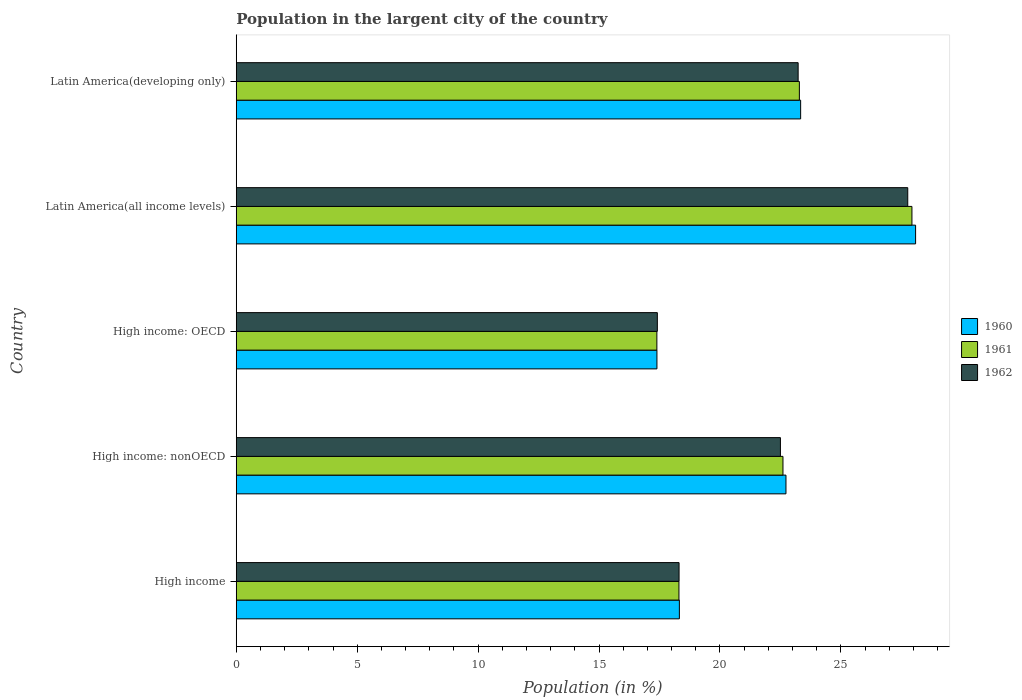Are the number of bars per tick equal to the number of legend labels?
Offer a terse response. Yes. What is the label of the 1st group of bars from the top?
Your answer should be compact. Latin America(developing only). What is the percentage of population in the largent city in 1962 in Latin America(developing only)?
Provide a short and direct response. 23.23. Across all countries, what is the maximum percentage of population in the largent city in 1960?
Give a very brief answer. 28.09. Across all countries, what is the minimum percentage of population in the largent city in 1961?
Your answer should be compact. 17.39. In which country was the percentage of population in the largent city in 1961 maximum?
Keep it short and to the point. Latin America(all income levels). In which country was the percentage of population in the largent city in 1962 minimum?
Your response must be concise. High income: OECD. What is the total percentage of population in the largent city in 1960 in the graph?
Offer a terse response. 109.87. What is the difference between the percentage of population in the largent city in 1962 in High income and that in High income: OECD?
Provide a short and direct response. 0.9. What is the difference between the percentage of population in the largent city in 1962 in High income: OECD and the percentage of population in the largent city in 1960 in Latin America(developing only)?
Your answer should be very brief. -5.93. What is the average percentage of population in the largent city in 1961 per country?
Your answer should be compact. 21.9. What is the difference between the percentage of population in the largent city in 1960 and percentage of population in the largent city in 1961 in Latin America(all income levels)?
Keep it short and to the point. 0.15. In how many countries, is the percentage of population in the largent city in 1961 greater than 10 %?
Your response must be concise. 5. What is the ratio of the percentage of population in the largent city in 1960 in High income to that in Latin America(all income levels)?
Offer a terse response. 0.65. What is the difference between the highest and the second highest percentage of population in the largent city in 1960?
Offer a terse response. 4.75. What is the difference between the highest and the lowest percentage of population in the largent city in 1962?
Make the answer very short. 10.35. Is the sum of the percentage of population in the largent city in 1960 in High income and High income: nonOECD greater than the maximum percentage of population in the largent city in 1961 across all countries?
Offer a very short reply. Yes. What does the 1st bar from the bottom in High income represents?
Offer a very short reply. 1960. How many countries are there in the graph?
Provide a short and direct response. 5. Are the values on the major ticks of X-axis written in scientific E-notation?
Your response must be concise. No. How are the legend labels stacked?
Offer a terse response. Vertical. What is the title of the graph?
Offer a terse response. Population in the largent city of the country. Does "1977" appear as one of the legend labels in the graph?
Ensure brevity in your answer.  No. What is the Population (in %) of 1960 in High income?
Offer a terse response. 18.32. What is the Population (in %) of 1961 in High income?
Your answer should be compact. 18.3. What is the Population (in %) in 1962 in High income?
Offer a terse response. 18.31. What is the Population (in %) in 1960 in High income: nonOECD?
Your answer should be very brief. 22.73. What is the Population (in %) of 1961 in High income: nonOECD?
Ensure brevity in your answer.  22.61. What is the Population (in %) in 1962 in High income: nonOECD?
Your response must be concise. 22.5. What is the Population (in %) of 1960 in High income: OECD?
Offer a very short reply. 17.39. What is the Population (in %) of 1961 in High income: OECD?
Keep it short and to the point. 17.39. What is the Population (in %) of 1962 in High income: OECD?
Make the answer very short. 17.41. What is the Population (in %) of 1960 in Latin America(all income levels)?
Offer a very short reply. 28.09. What is the Population (in %) of 1961 in Latin America(all income levels)?
Your answer should be compact. 27.94. What is the Population (in %) in 1962 in Latin America(all income levels)?
Your answer should be very brief. 27.76. What is the Population (in %) of 1960 in Latin America(developing only)?
Give a very brief answer. 23.34. What is the Population (in %) of 1961 in Latin America(developing only)?
Your answer should be compact. 23.28. What is the Population (in %) in 1962 in Latin America(developing only)?
Make the answer very short. 23.23. Across all countries, what is the maximum Population (in %) of 1960?
Your answer should be very brief. 28.09. Across all countries, what is the maximum Population (in %) of 1961?
Your answer should be very brief. 27.94. Across all countries, what is the maximum Population (in %) in 1962?
Ensure brevity in your answer.  27.76. Across all countries, what is the minimum Population (in %) of 1960?
Provide a succinct answer. 17.39. Across all countries, what is the minimum Population (in %) in 1961?
Give a very brief answer. 17.39. Across all countries, what is the minimum Population (in %) of 1962?
Provide a short and direct response. 17.41. What is the total Population (in %) of 1960 in the graph?
Keep it short and to the point. 109.87. What is the total Population (in %) of 1961 in the graph?
Give a very brief answer. 109.52. What is the total Population (in %) of 1962 in the graph?
Ensure brevity in your answer.  109.22. What is the difference between the Population (in %) of 1960 in High income and that in High income: nonOECD?
Your answer should be very brief. -4.41. What is the difference between the Population (in %) of 1961 in High income and that in High income: nonOECD?
Provide a succinct answer. -4.3. What is the difference between the Population (in %) in 1962 in High income and that in High income: nonOECD?
Provide a short and direct response. -4.19. What is the difference between the Population (in %) in 1960 in High income and that in High income: OECD?
Your response must be concise. 0.93. What is the difference between the Population (in %) of 1961 in High income and that in High income: OECD?
Give a very brief answer. 0.91. What is the difference between the Population (in %) of 1962 in High income and that in High income: OECD?
Provide a succinct answer. 0.9. What is the difference between the Population (in %) in 1960 in High income and that in Latin America(all income levels)?
Ensure brevity in your answer.  -9.77. What is the difference between the Population (in %) in 1961 in High income and that in Latin America(all income levels)?
Give a very brief answer. -9.63. What is the difference between the Population (in %) in 1962 in High income and that in Latin America(all income levels)?
Your answer should be compact. -9.46. What is the difference between the Population (in %) of 1960 in High income and that in Latin America(developing only)?
Provide a short and direct response. -5.01. What is the difference between the Population (in %) in 1961 in High income and that in Latin America(developing only)?
Ensure brevity in your answer.  -4.98. What is the difference between the Population (in %) in 1962 in High income and that in Latin America(developing only)?
Ensure brevity in your answer.  -4.92. What is the difference between the Population (in %) in 1960 in High income: nonOECD and that in High income: OECD?
Provide a short and direct response. 5.34. What is the difference between the Population (in %) of 1961 in High income: nonOECD and that in High income: OECD?
Your response must be concise. 5.21. What is the difference between the Population (in %) in 1962 in High income: nonOECD and that in High income: OECD?
Make the answer very short. 5.09. What is the difference between the Population (in %) in 1960 in High income: nonOECD and that in Latin America(all income levels)?
Make the answer very short. -5.36. What is the difference between the Population (in %) of 1961 in High income: nonOECD and that in Latin America(all income levels)?
Ensure brevity in your answer.  -5.33. What is the difference between the Population (in %) of 1962 in High income: nonOECD and that in Latin America(all income levels)?
Offer a very short reply. -5.26. What is the difference between the Population (in %) of 1960 in High income: nonOECD and that in Latin America(developing only)?
Offer a terse response. -0.61. What is the difference between the Population (in %) of 1961 in High income: nonOECD and that in Latin America(developing only)?
Provide a short and direct response. -0.68. What is the difference between the Population (in %) in 1962 in High income: nonOECD and that in Latin America(developing only)?
Provide a succinct answer. -0.73. What is the difference between the Population (in %) in 1960 in High income: OECD and that in Latin America(all income levels)?
Give a very brief answer. -10.69. What is the difference between the Population (in %) in 1961 in High income: OECD and that in Latin America(all income levels)?
Keep it short and to the point. -10.55. What is the difference between the Population (in %) in 1962 in High income: OECD and that in Latin America(all income levels)?
Your answer should be very brief. -10.35. What is the difference between the Population (in %) in 1960 in High income: OECD and that in Latin America(developing only)?
Offer a terse response. -5.94. What is the difference between the Population (in %) of 1961 in High income: OECD and that in Latin America(developing only)?
Make the answer very short. -5.89. What is the difference between the Population (in %) in 1962 in High income: OECD and that in Latin America(developing only)?
Offer a terse response. -5.82. What is the difference between the Population (in %) in 1960 in Latin America(all income levels) and that in Latin America(developing only)?
Your answer should be compact. 4.75. What is the difference between the Population (in %) of 1961 in Latin America(all income levels) and that in Latin America(developing only)?
Provide a short and direct response. 4.65. What is the difference between the Population (in %) in 1962 in Latin America(all income levels) and that in Latin America(developing only)?
Offer a very short reply. 4.53. What is the difference between the Population (in %) in 1960 in High income and the Population (in %) in 1961 in High income: nonOECD?
Offer a terse response. -4.28. What is the difference between the Population (in %) in 1960 in High income and the Population (in %) in 1962 in High income: nonOECD?
Keep it short and to the point. -4.18. What is the difference between the Population (in %) of 1961 in High income and the Population (in %) of 1962 in High income: nonOECD?
Your answer should be very brief. -4.2. What is the difference between the Population (in %) of 1960 in High income and the Population (in %) of 1961 in High income: OECD?
Your answer should be very brief. 0.93. What is the difference between the Population (in %) of 1960 in High income and the Population (in %) of 1962 in High income: OECD?
Provide a short and direct response. 0.91. What is the difference between the Population (in %) of 1961 in High income and the Population (in %) of 1962 in High income: OECD?
Ensure brevity in your answer.  0.89. What is the difference between the Population (in %) in 1960 in High income and the Population (in %) in 1961 in Latin America(all income levels)?
Offer a terse response. -9.62. What is the difference between the Population (in %) of 1960 in High income and the Population (in %) of 1962 in Latin America(all income levels)?
Your answer should be compact. -9.44. What is the difference between the Population (in %) of 1961 in High income and the Population (in %) of 1962 in Latin America(all income levels)?
Keep it short and to the point. -9.46. What is the difference between the Population (in %) of 1960 in High income and the Population (in %) of 1961 in Latin America(developing only)?
Your response must be concise. -4.96. What is the difference between the Population (in %) of 1960 in High income and the Population (in %) of 1962 in Latin America(developing only)?
Provide a short and direct response. -4.91. What is the difference between the Population (in %) of 1961 in High income and the Population (in %) of 1962 in Latin America(developing only)?
Offer a terse response. -4.93. What is the difference between the Population (in %) of 1960 in High income: nonOECD and the Population (in %) of 1961 in High income: OECD?
Keep it short and to the point. 5.34. What is the difference between the Population (in %) in 1960 in High income: nonOECD and the Population (in %) in 1962 in High income: OECD?
Offer a terse response. 5.32. What is the difference between the Population (in %) in 1961 in High income: nonOECD and the Population (in %) in 1962 in High income: OECD?
Offer a very short reply. 5.19. What is the difference between the Population (in %) of 1960 in High income: nonOECD and the Population (in %) of 1961 in Latin America(all income levels)?
Make the answer very short. -5.21. What is the difference between the Population (in %) of 1960 in High income: nonOECD and the Population (in %) of 1962 in Latin America(all income levels)?
Make the answer very short. -5.04. What is the difference between the Population (in %) in 1961 in High income: nonOECD and the Population (in %) in 1962 in Latin America(all income levels)?
Ensure brevity in your answer.  -5.16. What is the difference between the Population (in %) of 1960 in High income: nonOECD and the Population (in %) of 1961 in Latin America(developing only)?
Ensure brevity in your answer.  -0.55. What is the difference between the Population (in %) of 1960 in High income: nonOECD and the Population (in %) of 1962 in Latin America(developing only)?
Your answer should be compact. -0.5. What is the difference between the Population (in %) of 1961 in High income: nonOECD and the Population (in %) of 1962 in Latin America(developing only)?
Your answer should be very brief. -0.63. What is the difference between the Population (in %) of 1960 in High income: OECD and the Population (in %) of 1961 in Latin America(all income levels)?
Your response must be concise. -10.54. What is the difference between the Population (in %) of 1960 in High income: OECD and the Population (in %) of 1962 in Latin America(all income levels)?
Provide a succinct answer. -10.37. What is the difference between the Population (in %) in 1961 in High income: OECD and the Population (in %) in 1962 in Latin America(all income levels)?
Keep it short and to the point. -10.37. What is the difference between the Population (in %) in 1960 in High income: OECD and the Population (in %) in 1961 in Latin America(developing only)?
Give a very brief answer. -5.89. What is the difference between the Population (in %) of 1960 in High income: OECD and the Population (in %) of 1962 in Latin America(developing only)?
Provide a succinct answer. -5.84. What is the difference between the Population (in %) in 1961 in High income: OECD and the Population (in %) in 1962 in Latin America(developing only)?
Provide a succinct answer. -5.84. What is the difference between the Population (in %) in 1960 in Latin America(all income levels) and the Population (in %) in 1961 in Latin America(developing only)?
Keep it short and to the point. 4.8. What is the difference between the Population (in %) of 1960 in Latin America(all income levels) and the Population (in %) of 1962 in Latin America(developing only)?
Your response must be concise. 4.86. What is the difference between the Population (in %) in 1961 in Latin America(all income levels) and the Population (in %) in 1962 in Latin America(developing only)?
Your response must be concise. 4.71. What is the average Population (in %) of 1960 per country?
Your answer should be very brief. 21.97. What is the average Population (in %) in 1961 per country?
Give a very brief answer. 21.9. What is the average Population (in %) in 1962 per country?
Your response must be concise. 21.84. What is the difference between the Population (in %) in 1960 and Population (in %) in 1961 in High income?
Keep it short and to the point. 0.02. What is the difference between the Population (in %) of 1960 and Population (in %) of 1962 in High income?
Your response must be concise. 0.01. What is the difference between the Population (in %) of 1961 and Population (in %) of 1962 in High income?
Keep it short and to the point. -0. What is the difference between the Population (in %) of 1960 and Population (in %) of 1961 in High income: nonOECD?
Offer a very short reply. 0.12. What is the difference between the Population (in %) of 1960 and Population (in %) of 1962 in High income: nonOECD?
Provide a succinct answer. 0.23. What is the difference between the Population (in %) of 1961 and Population (in %) of 1962 in High income: nonOECD?
Your answer should be very brief. 0.11. What is the difference between the Population (in %) in 1960 and Population (in %) in 1961 in High income: OECD?
Offer a terse response. 0. What is the difference between the Population (in %) in 1960 and Population (in %) in 1962 in High income: OECD?
Make the answer very short. -0.02. What is the difference between the Population (in %) in 1961 and Population (in %) in 1962 in High income: OECD?
Offer a very short reply. -0.02. What is the difference between the Population (in %) in 1960 and Population (in %) in 1961 in Latin America(all income levels)?
Give a very brief answer. 0.15. What is the difference between the Population (in %) in 1960 and Population (in %) in 1962 in Latin America(all income levels)?
Make the answer very short. 0.32. What is the difference between the Population (in %) of 1961 and Population (in %) of 1962 in Latin America(all income levels)?
Keep it short and to the point. 0.17. What is the difference between the Population (in %) of 1960 and Population (in %) of 1961 in Latin America(developing only)?
Provide a succinct answer. 0.05. What is the difference between the Population (in %) in 1960 and Population (in %) in 1962 in Latin America(developing only)?
Your answer should be very brief. 0.1. What is the difference between the Population (in %) of 1961 and Population (in %) of 1962 in Latin America(developing only)?
Offer a terse response. 0.05. What is the ratio of the Population (in %) in 1960 in High income to that in High income: nonOECD?
Your response must be concise. 0.81. What is the ratio of the Population (in %) in 1961 in High income to that in High income: nonOECD?
Your answer should be very brief. 0.81. What is the ratio of the Population (in %) in 1962 in High income to that in High income: nonOECD?
Provide a short and direct response. 0.81. What is the ratio of the Population (in %) in 1960 in High income to that in High income: OECD?
Make the answer very short. 1.05. What is the ratio of the Population (in %) of 1961 in High income to that in High income: OECD?
Your answer should be very brief. 1.05. What is the ratio of the Population (in %) of 1962 in High income to that in High income: OECD?
Provide a short and direct response. 1.05. What is the ratio of the Population (in %) of 1960 in High income to that in Latin America(all income levels)?
Make the answer very short. 0.65. What is the ratio of the Population (in %) of 1961 in High income to that in Latin America(all income levels)?
Give a very brief answer. 0.66. What is the ratio of the Population (in %) in 1962 in High income to that in Latin America(all income levels)?
Give a very brief answer. 0.66. What is the ratio of the Population (in %) in 1960 in High income to that in Latin America(developing only)?
Keep it short and to the point. 0.79. What is the ratio of the Population (in %) of 1961 in High income to that in Latin America(developing only)?
Provide a short and direct response. 0.79. What is the ratio of the Population (in %) of 1962 in High income to that in Latin America(developing only)?
Ensure brevity in your answer.  0.79. What is the ratio of the Population (in %) of 1960 in High income: nonOECD to that in High income: OECD?
Give a very brief answer. 1.31. What is the ratio of the Population (in %) of 1961 in High income: nonOECD to that in High income: OECD?
Your answer should be compact. 1.3. What is the ratio of the Population (in %) of 1962 in High income: nonOECD to that in High income: OECD?
Give a very brief answer. 1.29. What is the ratio of the Population (in %) in 1960 in High income: nonOECD to that in Latin America(all income levels)?
Offer a very short reply. 0.81. What is the ratio of the Population (in %) in 1961 in High income: nonOECD to that in Latin America(all income levels)?
Offer a terse response. 0.81. What is the ratio of the Population (in %) of 1962 in High income: nonOECD to that in Latin America(all income levels)?
Keep it short and to the point. 0.81. What is the ratio of the Population (in %) of 1961 in High income: nonOECD to that in Latin America(developing only)?
Provide a succinct answer. 0.97. What is the ratio of the Population (in %) in 1962 in High income: nonOECD to that in Latin America(developing only)?
Provide a short and direct response. 0.97. What is the ratio of the Population (in %) of 1960 in High income: OECD to that in Latin America(all income levels)?
Offer a terse response. 0.62. What is the ratio of the Population (in %) of 1961 in High income: OECD to that in Latin America(all income levels)?
Your answer should be very brief. 0.62. What is the ratio of the Population (in %) of 1962 in High income: OECD to that in Latin America(all income levels)?
Ensure brevity in your answer.  0.63. What is the ratio of the Population (in %) in 1960 in High income: OECD to that in Latin America(developing only)?
Your response must be concise. 0.75. What is the ratio of the Population (in %) of 1961 in High income: OECD to that in Latin America(developing only)?
Give a very brief answer. 0.75. What is the ratio of the Population (in %) of 1962 in High income: OECD to that in Latin America(developing only)?
Provide a short and direct response. 0.75. What is the ratio of the Population (in %) in 1960 in Latin America(all income levels) to that in Latin America(developing only)?
Provide a succinct answer. 1.2. What is the ratio of the Population (in %) of 1961 in Latin America(all income levels) to that in Latin America(developing only)?
Your answer should be compact. 1.2. What is the ratio of the Population (in %) of 1962 in Latin America(all income levels) to that in Latin America(developing only)?
Offer a terse response. 1.2. What is the difference between the highest and the second highest Population (in %) of 1960?
Offer a very short reply. 4.75. What is the difference between the highest and the second highest Population (in %) of 1961?
Keep it short and to the point. 4.65. What is the difference between the highest and the second highest Population (in %) of 1962?
Ensure brevity in your answer.  4.53. What is the difference between the highest and the lowest Population (in %) of 1960?
Provide a short and direct response. 10.69. What is the difference between the highest and the lowest Population (in %) of 1961?
Keep it short and to the point. 10.55. What is the difference between the highest and the lowest Population (in %) of 1962?
Keep it short and to the point. 10.35. 